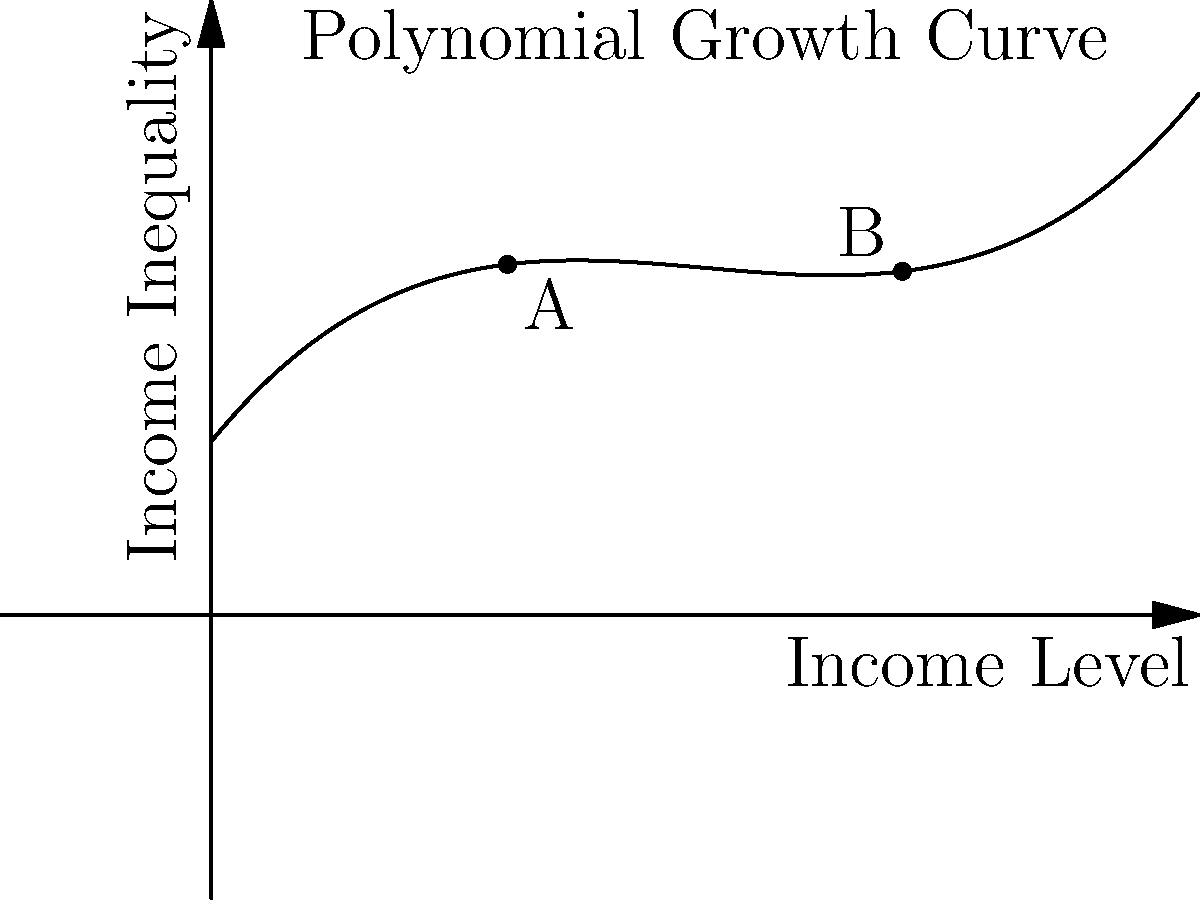The graph shows a polynomial curve representing the relationship between income level and income inequality. If this model accurately represents societal trends, what does the shape of the curve suggest about the impact of increasing income levels on income inequality, particularly when comparing points A and B? To analyze this relationship, let's follow these steps:

1. Observe the overall shape: The curve is a cubic polynomial, showing a complex relationship between income level and inequality.

2. Examine the curve's behavior:
   - Initially, as income levels increase from 0, inequality rises slowly.
   - Around point A, the curve's slope decreases, indicating a slowing rate of inequality growth.
   - After point A, the curve begins to rise more steeply.
   - At point B, the curve is rising rapidly, suggesting accelerating inequality.

3. Compare points A and B:
   - Point A (lower income level) shows moderate inequality and a gentler slope.
   - Point B (higher income level) shows higher inequality and a steeper slope.

4. Interpret the implications:
   - The model suggests that as society's overall income level increases, income inequality tends to grow.
   - The rate of inequality growth accelerates at higher income levels, implying that economic growth without intervention may exacerbate wealth gaps.
   - This pattern aligns with the concept of "the rich getting richer," where initial wealth advantages compound over time.

5. Consider policy implications:
   - The curve suggests that passive economic growth alone may not reduce inequality.
   - Progressive policies might be necessary to flatten the curve at higher income levels.
   - Interventions could include progressive taxation, social programs, or wealth redistribution measures.

This model provides a data-driven basis for discussing the complex relationship between economic growth and inequality, supporting arguments for proactive policy measures to address wealth disparity in growing economies.
Answer: The curve suggests that income inequality accelerates as income levels rise, with a more rapid increase in inequality at higher income levels (point B) compared to lower levels (point A), implying that economic growth alone may exacerbate wealth disparity without targeted interventions. 